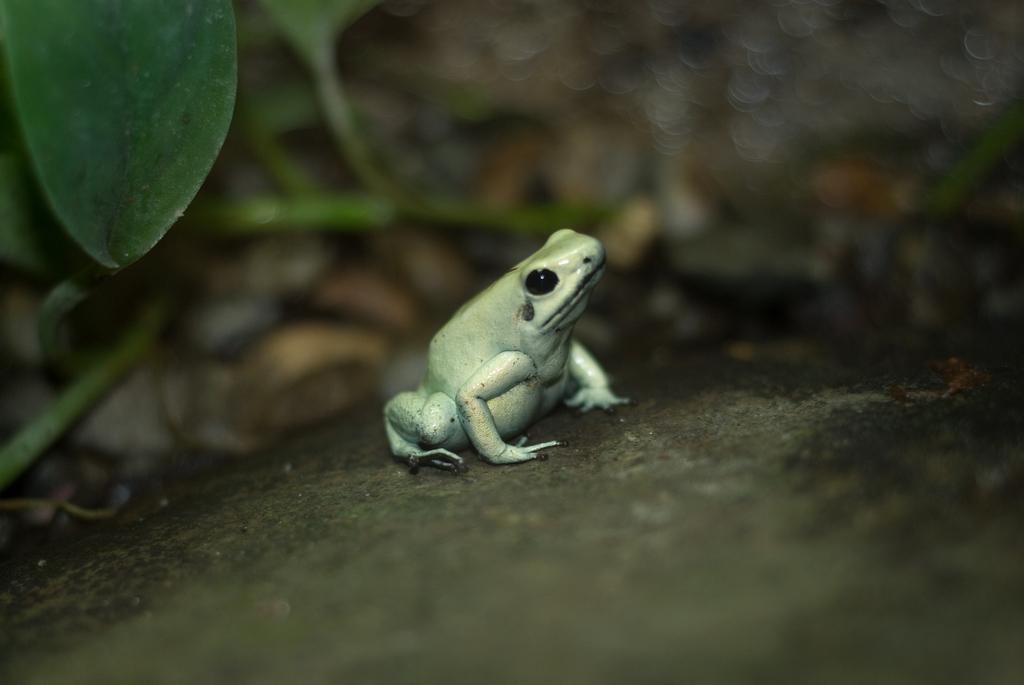Can you describe this image briefly? In this image I can see a frog in green color on the rock. Background I can see few leaves in green color. 